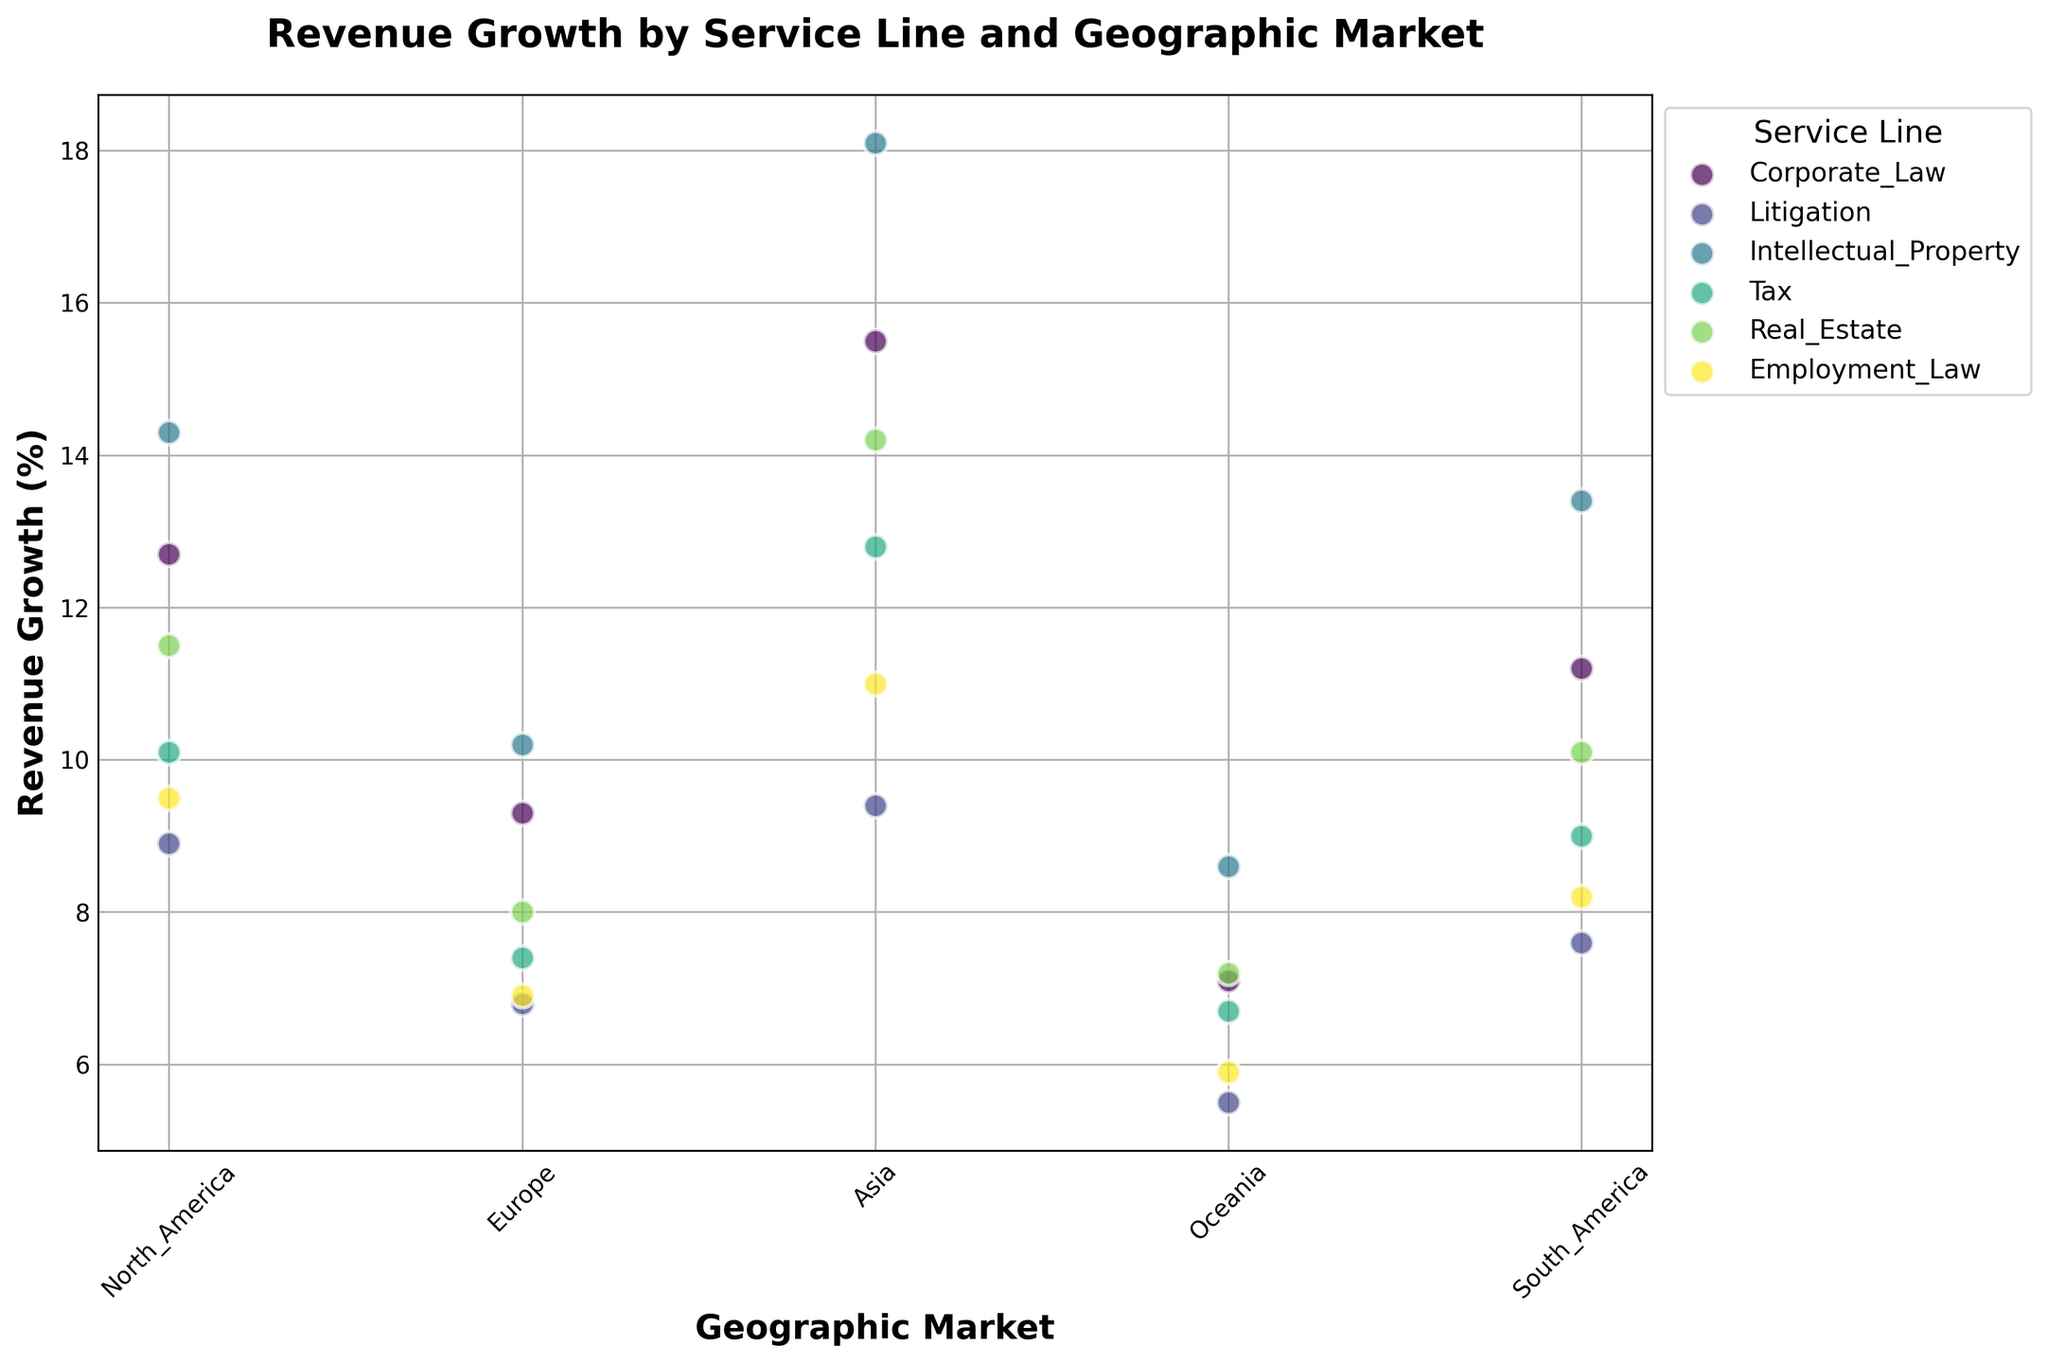Which service line has the highest revenue growth in the Asia market? Check the scatter plot for data points in the Asia market and compare their revenue growth values. Intellectual Property shows the highest value.
Answer: Intellectual Property What is the difference in revenue growth between Corporate Law and Employment Law in North America? Locate the North America data points for both Corporate Law and Employment Law. Subtract Employment Law's value from Corporate Law's value (12.7 - 9.5).
Answer: 3.2 Which geographic market shows the smallest revenue growth for Real Estate? Compare the revenue growth values for Real Estate across all geographic markets. Oceania has the smallest value.
Answer: Oceania What is the average revenue growth for Litigation across all geographic markets? Sum up the revenue growth values for Litigation in all markets and divide by the number of markets: (8.9 + 6.8 + 9.4 + 5.5 + 7.6) / 5.
Answer: 7.64 In which market does Tax have higher revenue growth compared to Corporate Law? Compare the values of Tax and Corporate Law in each market. Tax has higher revenue growth in Europe (7.4 vs 9.3), Oceania (6.7 vs 7.1), and South America (9.0 vs 11.2).
Answer: None Which service line has the most consistent revenue growth across all markets based on visual dispersion? Look for the service line with data points that are least spread out on the y-axis (revenue growth). Tax and Real Estate appear to have the most consistent growth.
Answer: Tax or Real Estate What is the total revenue growth for Intellectual Property in Europe and Asia combined? Add the revenue growth values for Intellectual Property in Europe and Asia: (10.2 + 18.1).
Answer: 28.3 Which geographic market exhibits the highest revenue growth overall? Identify the data point with the highest revenue growth across all service lines and markets. Asia for Intellectual Property has the highest value.
Answer: Asia For how many geographic markets does Employment Law outperform Litigation in revenue growth? Compare the values of Employment Law and Litigation in each market. Employment Law outperforms Litigation in zero markets (9.5 vs 8.9, 6.9 vs 6.8, 11.0 vs 9.4, 5.9 vs 5.5, 8.2 vs 7.6).
Answer: 0 What is the median revenue growth for the Corporate Law service line across all markets? Order the revenue growth values for Corporate Law and find the middle number: (7.1, 9.3, 11.2, 12.7, 15.5).
Answer: 11.2 